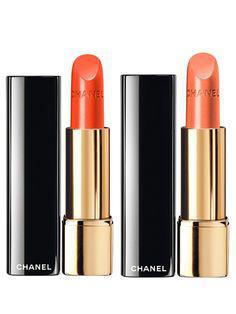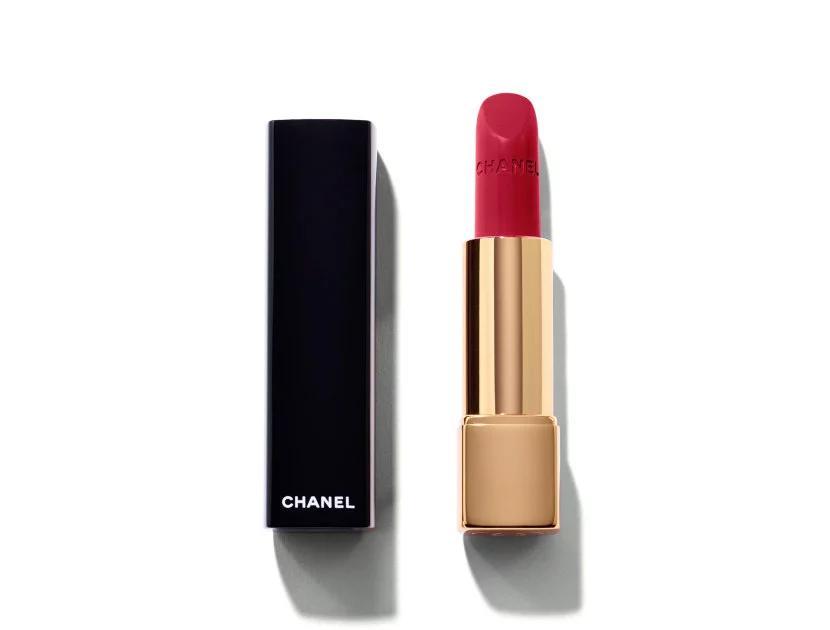The first image is the image on the left, the second image is the image on the right. Considering the images on both sides, is "One image contains a single lipstick next to its lid, and the other image contains multiple lipsticks next to their lids." valid? Answer yes or no. Yes. The first image is the image on the left, the second image is the image on the right. For the images shown, is this caption "There are more than one lipsticks in one of the images." true? Answer yes or no. Yes. 